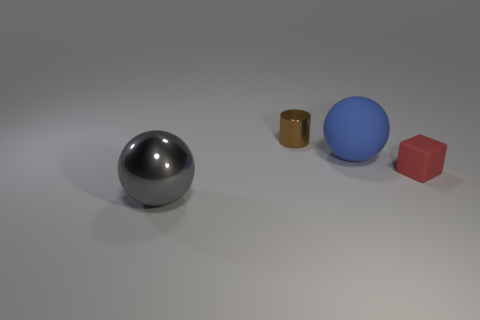Add 3 small purple metal blocks. How many objects exist? 7 Subtract all cylinders. How many objects are left? 3 Subtract all tiny yellow shiny balls. Subtract all rubber cubes. How many objects are left? 3 Add 1 big balls. How many big balls are left? 3 Add 4 large gray objects. How many large gray objects exist? 5 Subtract 0 yellow balls. How many objects are left? 4 